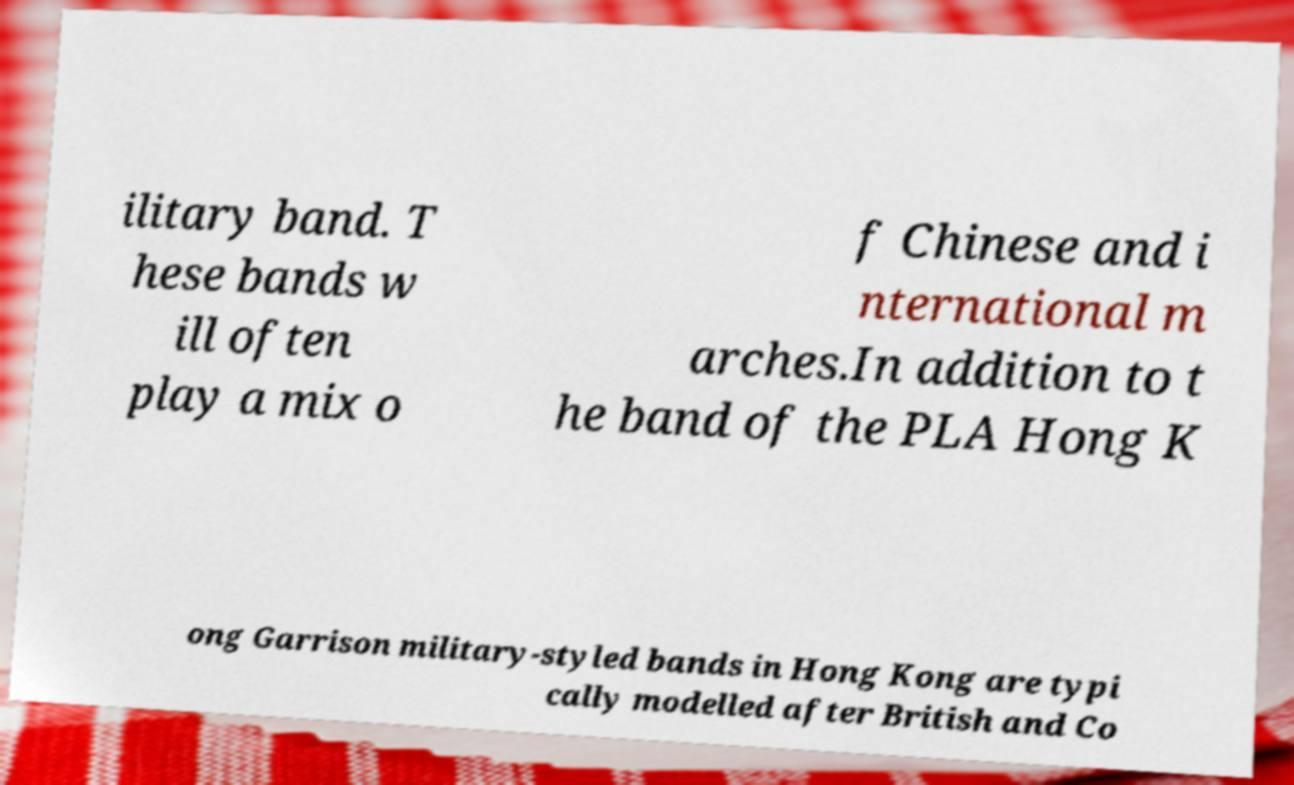I need the written content from this picture converted into text. Can you do that? ilitary band. T hese bands w ill often play a mix o f Chinese and i nternational m arches.In addition to t he band of the PLA Hong K ong Garrison military-styled bands in Hong Kong are typi cally modelled after British and Co 